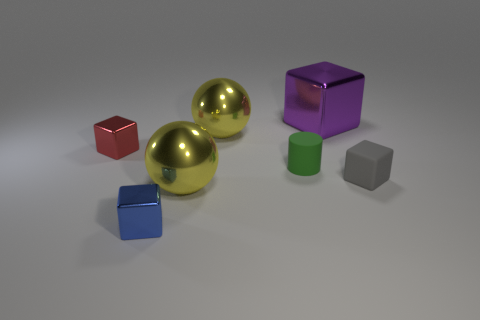How many brown things are either metal cubes or big metal objects?
Provide a succinct answer. 0. What is the thing on the left side of the small blue metallic block made of?
Offer a terse response. Metal. Are the big ball that is in front of the small cylinder and the small green thing made of the same material?
Make the answer very short. No. What shape is the small green rubber object?
Keep it short and to the point. Cylinder. There is a metal ball in front of the small shiny object that is behind the blue metallic cube; what number of blue objects are behind it?
Offer a very short reply. 0. How many other things are there of the same material as the gray block?
Your answer should be compact. 1. There is a cylinder that is the same size as the gray rubber block; what material is it?
Keep it short and to the point. Rubber. There is a big metal sphere that is in front of the tiny green thing; does it have the same color as the big metallic sphere behind the gray thing?
Offer a terse response. Yes. Is there another small matte thing of the same shape as the small blue thing?
Your response must be concise. Yes. There is a red metal object that is the same size as the gray block; what is its shape?
Give a very brief answer. Cube. 